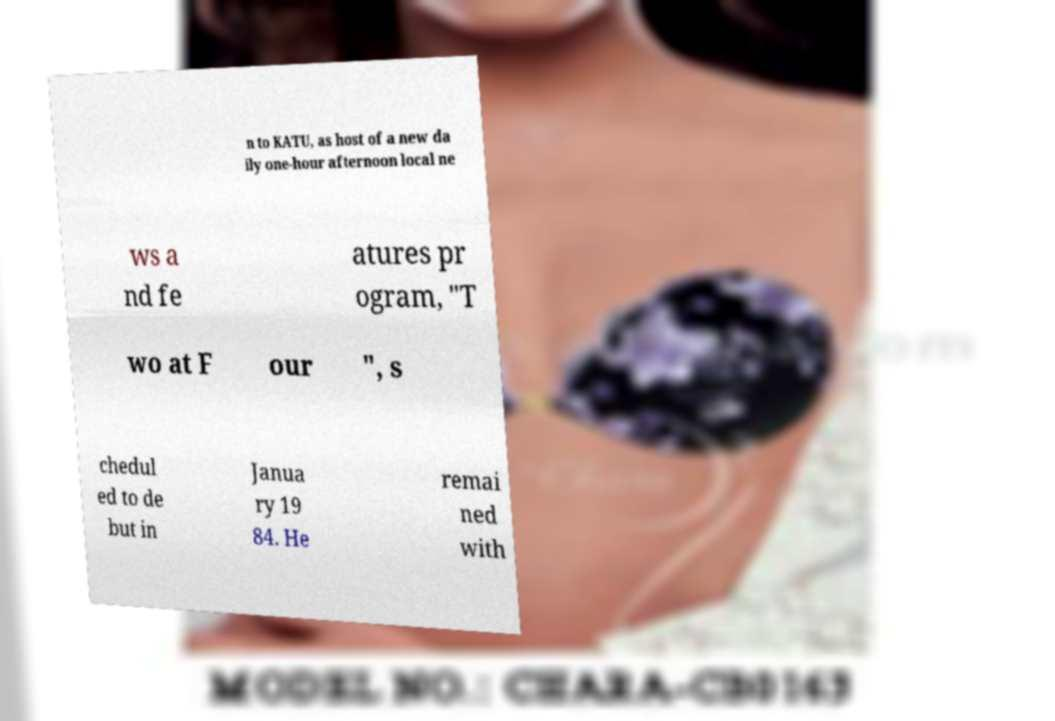What messages or text are displayed in this image? I need them in a readable, typed format. n to KATU, as host of a new da ily one-hour afternoon local ne ws a nd fe atures pr ogram, "T wo at F our ", s chedul ed to de but in Janua ry 19 84. He remai ned with 